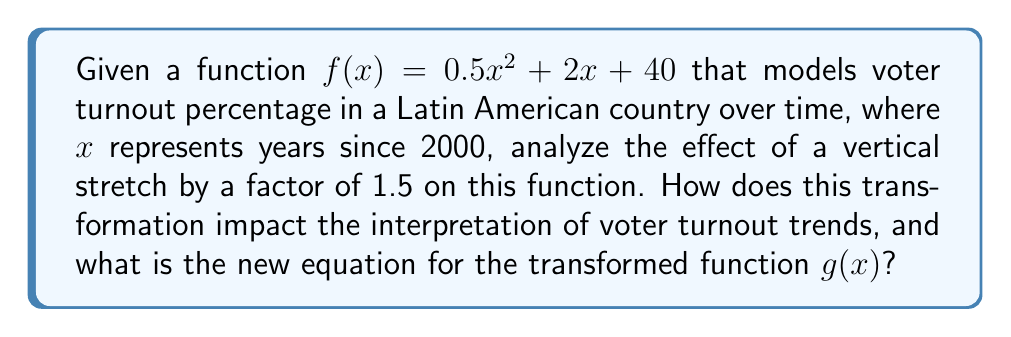Can you answer this question? To analyze the effect of a vertical stretch on the given function, we'll follow these steps:

1) The general form of a vertical stretch is given by:
   $g(x) = a \cdot f(x)$, where $a$ is the stretch factor

2) In this case, we're given a stretch factor of 1.5, so:
   $g(x) = 1.5 \cdot f(x)$

3) Substituting the original function:
   $g(x) = 1.5 \cdot (0.5x^2 + 2x + 40)$

4) Distributing the 1.5:
   $g(x) = 1.5(0.5x^2) + 1.5(2x) + 1.5(40)$

5) Simplifying:
   $g(x) = 0.75x^2 + 3x + 60$

Interpretation:
- The coefficient of $x^2$ has increased from 0.5 to 0.75, indicating a steeper parabola.
- The coefficient of $x$ has increased from 2 to 3, suggesting a more rapid initial increase.
- The constant term has increased from 40 to 60, implying a higher starting point.

In the context of voter turnout:
- The higher starting point (60% instead of 40%) suggests a more engaged electorate from the beginning.
- The steeper curve indicates more dramatic changes in voter turnout over time.
- This transformation could represent a scenario where voter engagement initiatives have been particularly effective, or where political events have significantly increased public interest in elections.

It's important to note that while the shape of the curve has been exaggerated, the general trend remains the same. This transformation doesn't change the years where turnout increases or decreases, but it does amplify the magnitude of these changes.
Answer: The new equation for the transformed function is $g(x) = 0.75x^2 + 3x + 60$. This vertical stretch amplifies the voter turnout trends, suggesting more dramatic changes in electoral participation over time while maintaining the same general pattern as the original function. 